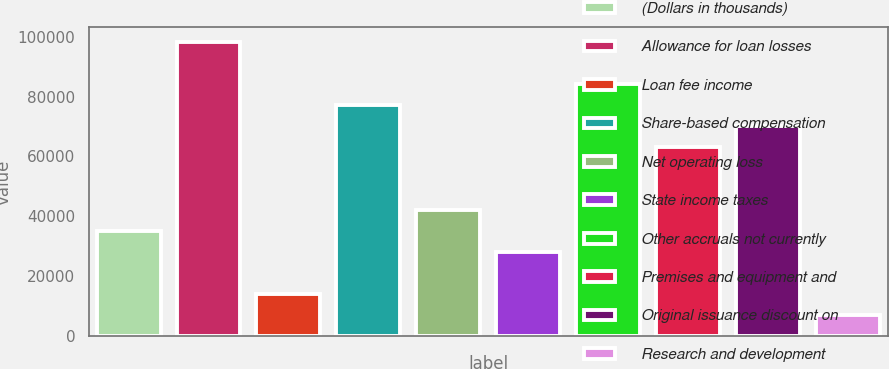Convert chart to OTSL. <chart><loc_0><loc_0><loc_500><loc_500><bar_chart><fcel>(Dollars in thousands)<fcel>Allowance for loan losses<fcel>Loan fee income<fcel>Share-based compensation<fcel>Net operating loss<fcel>State income taxes<fcel>Other accruals not currently<fcel>Premises and equipment and<fcel>Original issuance discount on<fcel>Research and development<nl><fcel>35060<fcel>98124.8<fcel>14038.4<fcel>77103.2<fcel>42067.2<fcel>28052.8<fcel>84110.4<fcel>63088.8<fcel>70096<fcel>7031.2<nl></chart> 